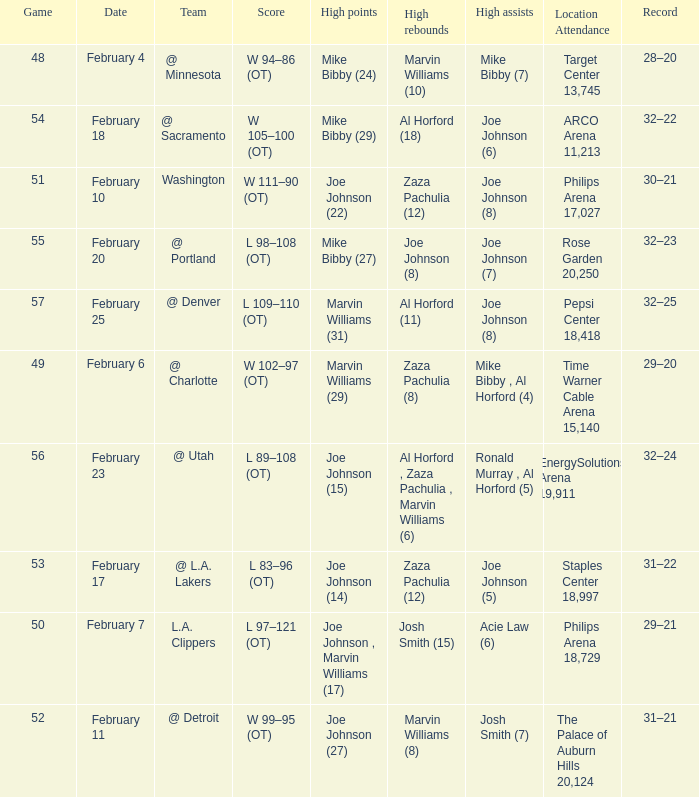How many high assists stats were maade on february 4 1.0. 